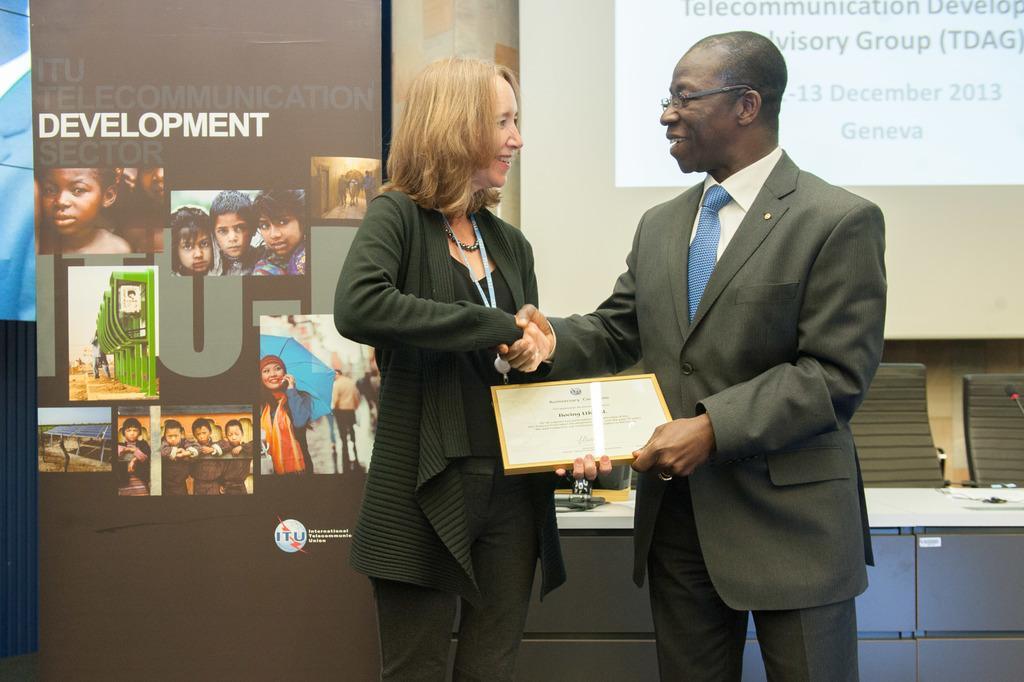How would you summarize this image in a sentence or two? There are two people standing and smiling and holding frame. In the background we can see banner and screen. We can see objects on the table. 